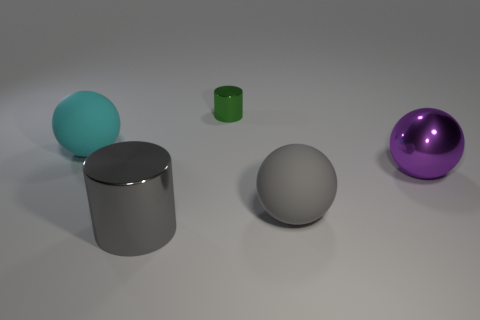What number of spheres are large cyan things or tiny green shiny things?
Make the answer very short. 1. There is a sphere that is the same color as the big metal cylinder; what material is it?
Provide a succinct answer. Rubber. There is a small cylinder; does it have the same color as the big ball on the left side of the gray shiny object?
Provide a succinct answer. No. The tiny cylinder has what color?
Give a very brief answer. Green. How many objects are large metal objects or metallic things?
Your response must be concise. 3. There is a purple sphere that is the same size as the cyan sphere; what is its material?
Provide a succinct answer. Metal. How big is the sphere in front of the metal ball?
Keep it short and to the point. Large. What material is the cyan sphere?
Your answer should be very brief. Rubber. How many objects are cylinders in front of the gray rubber object or large gray objects in front of the large gray matte thing?
Ensure brevity in your answer.  1. What number of other things are there of the same color as the small thing?
Your answer should be very brief. 0. 